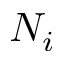<formula> <loc_0><loc_0><loc_500><loc_500>N _ { i }</formula> 